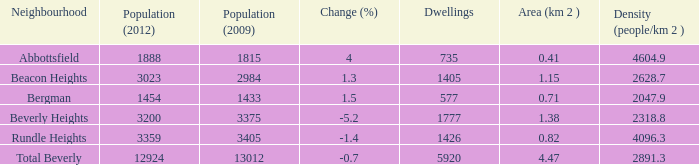What is the population density of a region with an area of 1.38 km and over 12,924 inhabitants? 0.0. 